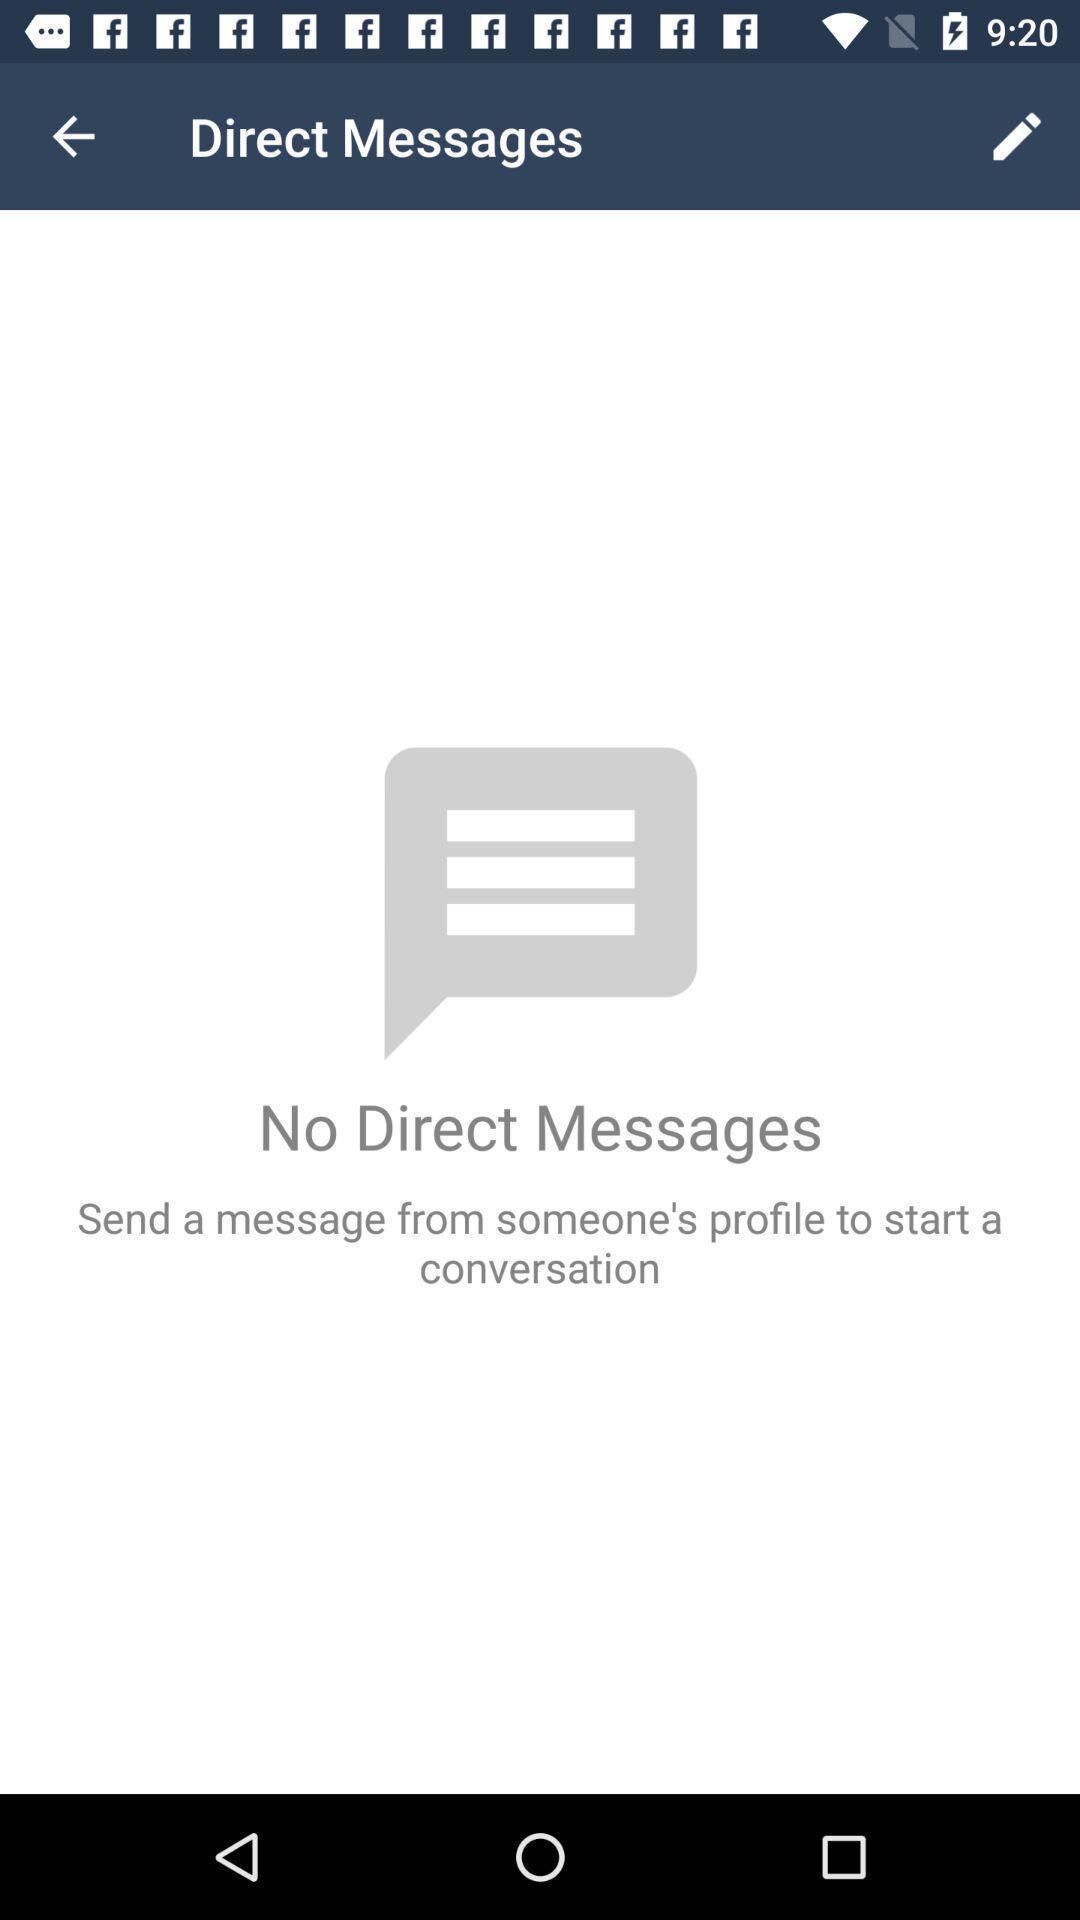What details can you identify in this image? Page showing different categories of messages. 